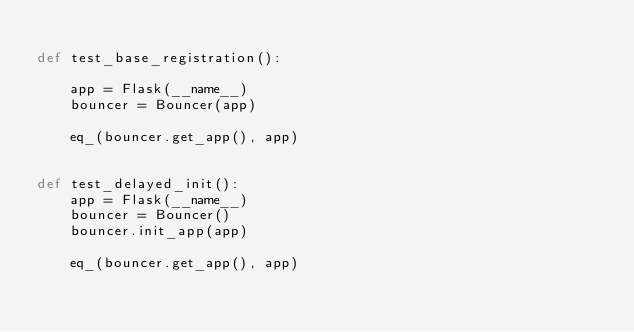<code> <loc_0><loc_0><loc_500><loc_500><_Python_>
def test_base_registration():

    app = Flask(__name__)
    bouncer = Bouncer(app)

    eq_(bouncer.get_app(), app)


def test_delayed_init():
    app = Flask(__name__)
    bouncer = Bouncer()
    bouncer.init_app(app)

    eq_(bouncer.get_app(), app)
</code> 